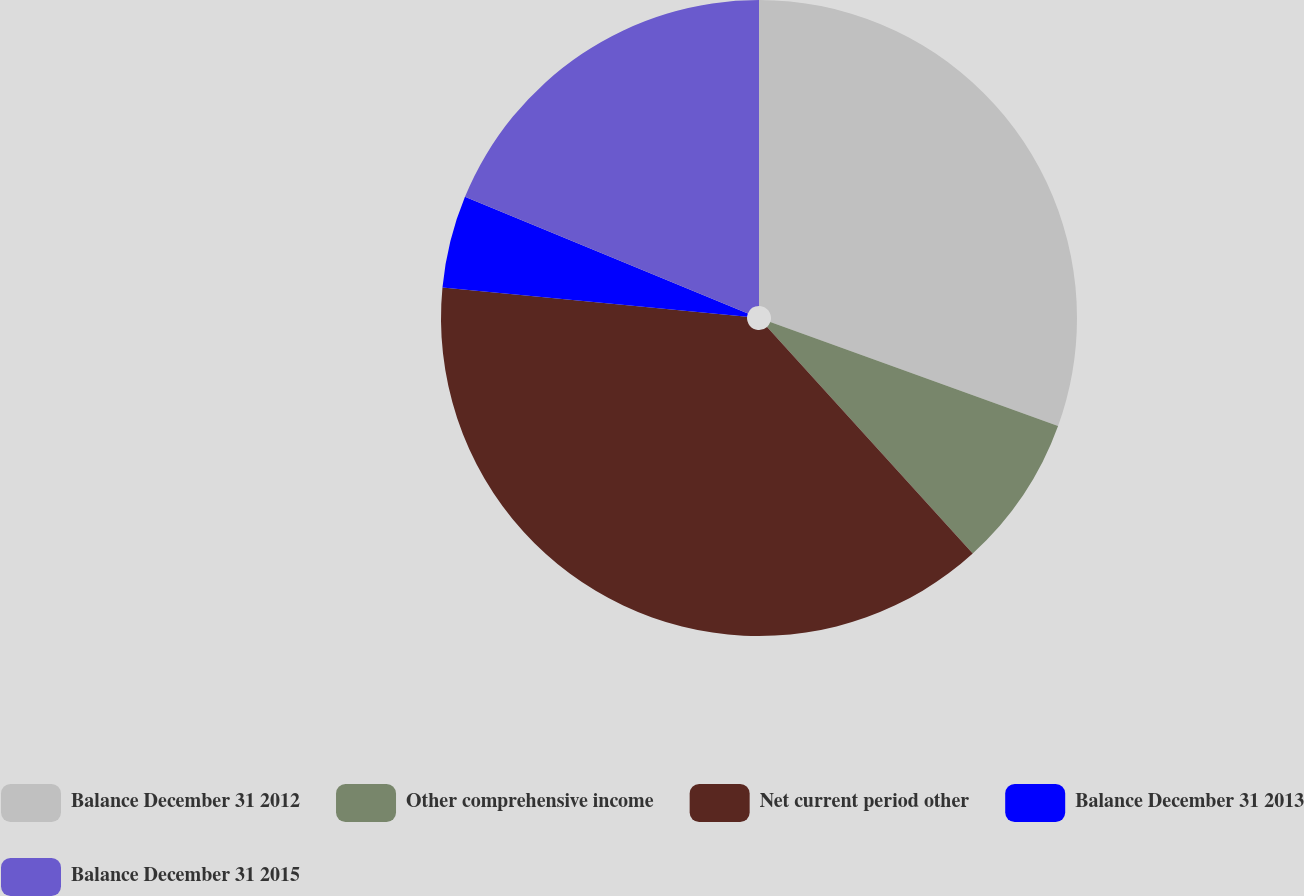<chart> <loc_0><loc_0><loc_500><loc_500><pie_chart><fcel>Balance December 31 2012<fcel>Other comprehensive income<fcel>Net current period other<fcel>Balance December 31 2013<fcel>Balance December 31 2015<nl><fcel>30.52%<fcel>7.75%<fcel>38.26%<fcel>4.69%<fcel>18.78%<nl></chart> 